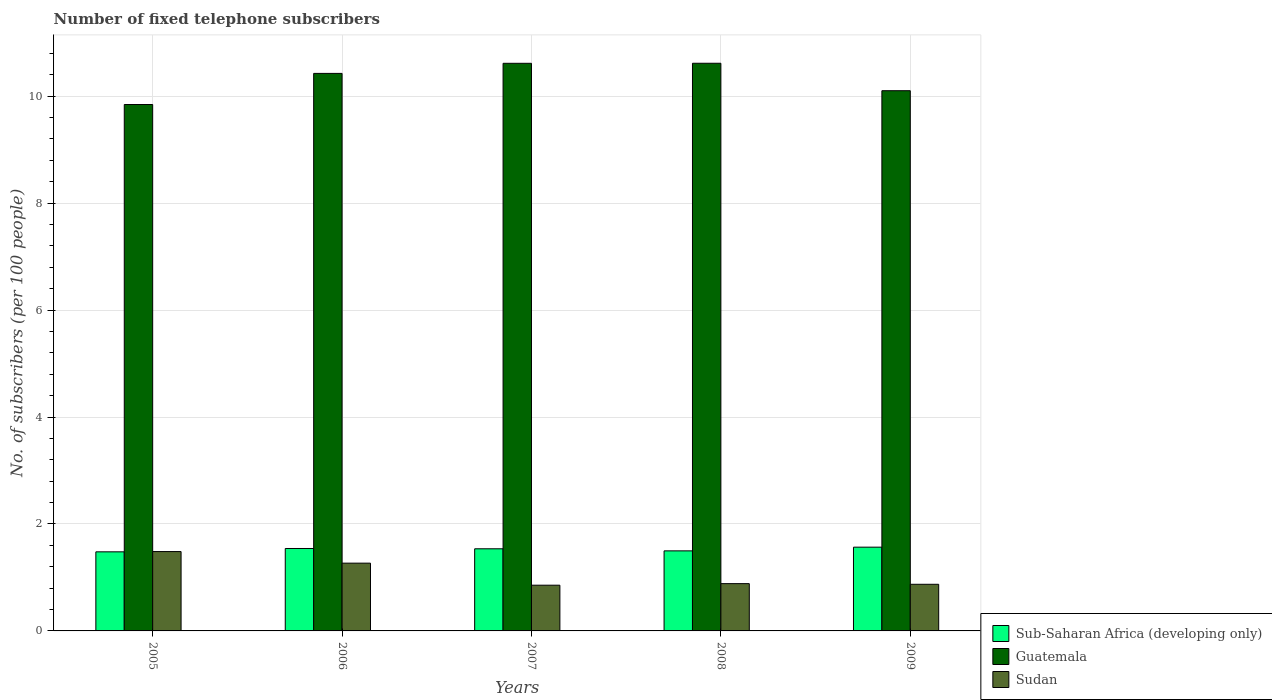How many different coloured bars are there?
Your answer should be very brief. 3. How many groups of bars are there?
Your answer should be compact. 5. Are the number of bars per tick equal to the number of legend labels?
Your response must be concise. Yes. How many bars are there on the 4th tick from the left?
Your answer should be compact. 3. What is the number of fixed telephone subscribers in Sub-Saharan Africa (developing only) in 2007?
Provide a short and direct response. 1.54. Across all years, what is the maximum number of fixed telephone subscribers in Sub-Saharan Africa (developing only)?
Your answer should be very brief. 1.57. Across all years, what is the minimum number of fixed telephone subscribers in Sub-Saharan Africa (developing only)?
Your answer should be compact. 1.48. In which year was the number of fixed telephone subscribers in Sudan maximum?
Provide a short and direct response. 2005. What is the total number of fixed telephone subscribers in Guatemala in the graph?
Provide a short and direct response. 51.6. What is the difference between the number of fixed telephone subscribers in Guatemala in 2007 and that in 2008?
Offer a very short reply. -0. What is the difference between the number of fixed telephone subscribers in Sub-Saharan Africa (developing only) in 2008 and the number of fixed telephone subscribers in Sudan in 2006?
Your answer should be very brief. 0.23. What is the average number of fixed telephone subscribers in Guatemala per year?
Ensure brevity in your answer.  10.32. In the year 2009, what is the difference between the number of fixed telephone subscribers in Sudan and number of fixed telephone subscribers in Guatemala?
Give a very brief answer. -9.23. What is the ratio of the number of fixed telephone subscribers in Sub-Saharan Africa (developing only) in 2005 to that in 2007?
Offer a very short reply. 0.96. Is the number of fixed telephone subscribers in Sub-Saharan Africa (developing only) in 2008 less than that in 2009?
Keep it short and to the point. Yes. Is the difference between the number of fixed telephone subscribers in Sudan in 2005 and 2006 greater than the difference between the number of fixed telephone subscribers in Guatemala in 2005 and 2006?
Offer a very short reply. Yes. What is the difference between the highest and the second highest number of fixed telephone subscribers in Guatemala?
Offer a very short reply. 0. What is the difference between the highest and the lowest number of fixed telephone subscribers in Sudan?
Your answer should be very brief. 0.63. What does the 3rd bar from the left in 2007 represents?
Keep it short and to the point. Sudan. What does the 3rd bar from the right in 2008 represents?
Provide a succinct answer. Sub-Saharan Africa (developing only). Is it the case that in every year, the sum of the number of fixed telephone subscribers in Sudan and number of fixed telephone subscribers in Sub-Saharan Africa (developing only) is greater than the number of fixed telephone subscribers in Guatemala?
Offer a terse response. No. How many bars are there?
Keep it short and to the point. 15. Are all the bars in the graph horizontal?
Your answer should be compact. No. How many years are there in the graph?
Offer a very short reply. 5. What is the difference between two consecutive major ticks on the Y-axis?
Your answer should be very brief. 2. Are the values on the major ticks of Y-axis written in scientific E-notation?
Your answer should be very brief. No. Does the graph contain any zero values?
Give a very brief answer. No. How many legend labels are there?
Make the answer very short. 3. What is the title of the graph?
Keep it short and to the point. Number of fixed telephone subscribers. What is the label or title of the X-axis?
Keep it short and to the point. Years. What is the label or title of the Y-axis?
Give a very brief answer. No. of subscribers (per 100 people). What is the No. of subscribers (per 100 people) in Sub-Saharan Africa (developing only) in 2005?
Your response must be concise. 1.48. What is the No. of subscribers (per 100 people) in Guatemala in 2005?
Give a very brief answer. 9.84. What is the No. of subscribers (per 100 people) of Sudan in 2005?
Give a very brief answer. 1.48. What is the No. of subscribers (per 100 people) of Sub-Saharan Africa (developing only) in 2006?
Give a very brief answer. 1.54. What is the No. of subscribers (per 100 people) of Guatemala in 2006?
Your response must be concise. 10.43. What is the No. of subscribers (per 100 people) of Sudan in 2006?
Offer a very short reply. 1.27. What is the No. of subscribers (per 100 people) in Sub-Saharan Africa (developing only) in 2007?
Offer a terse response. 1.54. What is the No. of subscribers (per 100 people) of Guatemala in 2007?
Offer a very short reply. 10.61. What is the No. of subscribers (per 100 people) in Sudan in 2007?
Ensure brevity in your answer.  0.85. What is the No. of subscribers (per 100 people) in Sub-Saharan Africa (developing only) in 2008?
Your answer should be very brief. 1.5. What is the No. of subscribers (per 100 people) of Guatemala in 2008?
Give a very brief answer. 10.62. What is the No. of subscribers (per 100 people) in Sudan in 2008?
Offer a terse response. 0.88. What is the No. of subscribers (per 100 people) in Sub-Saharan Africa (developing only) in 2009?
Give a very brief answer. 1.57. What is the No. of subscribers (per 100 people) of Guatemala in 2009?
Provide a succinct answer. 10.1. What is the No. of subscribers (per 100 people) in Sudan in 2009?
Ensure brevity in your answer.  0.87. Across all years, what is the maximum No. of subscribers (per 100 people) of Sub-Saharan Africa (developing only)?
Give a very brief answer. 1.57. Across all years, what is the maximum No. of subscribers (per 100 people) of Guatemala?
Make the answer very short. 10.62. Across all years, what is the maximum No. of subscribers (per 100 people) in Sudan?
Your response must be concise. 1.48. Across all years, what is the minimum No. of subscribers (per 100 people) in Sub-Saharan Africa (developing only)?
Your answer should be very brief. 1.48. Across all years, what is the minimum No. of subscribers (per 100 people) in Guatemala?
Ensure brevity in your answer.  9.84. Across all years, what is the minimum No. of subscribers (per 100 people) of Sudan?
Give a very brief answer. 0.85. What is the total No. of subscribers (per 100 people) of Sub-Saharan Africa (developing only) in the graph?
Offer a terse response. 7.62. What is the total No. of subscribers (per 100 people) of Guatemala in the graph?
Your answer should be compact. 51.6. What is the total No. of subscribers (per 100 people) of Sudan in the graph?
Offer a very short reply. 5.36. What is the difference between the No. of subscribers (per 100 people) in Sub-Saharan Africa (developing only) in 2005 and that in 2006?
Your response must be concise. -0.06. What is the difference between the No. of subscribers (per 100 people) of Guatemala in 2005 and that in 2006?
Your answer should be compact. -0.58. What is the difference between the No. of subscribers (per 100 people) of Sudan in 2005 and that in 2006?
Provide a succinct answer. 0.22. What is the difference between the No. of subscribers (per 100 people) of Sub-Saharan Africa (developing only) in 2005 and that in 2007?
Offer a terse response. -0.06. What is the difference between the No. of subscribers (per 100 people) in Guatemala in 2005 and that in 2007?
Offer a very short reply. -0.77. What is the difference between the No. of subscribers (per 100 people) of Sudan in 2005 and that in 2007?
Make the answer very short. 0.63. What is the difference between the No. of subscribers (per 100 people) in Sub-Saharan Africa (developing only) in 2005 and that in 2008?
Give a very brief answer. -0.02. What is the difference between the No. of subscribers (per 100 people) of Guatemala in 2005 and that in 2008?
Provide a succinct answer. -0.77. What is the difference between the No. of subscribers (per 100 people) in Sudan in 2005 and that in 2008?
Offer a very short reply. 0.6. What is the difference between the No. of subscribers (per 100 people) in Sub-Saharan Africa (developing only) in 2005 and that in 2009?
Your response must be concise. -0.09. What is the difference between the No. of subscribers (per 100 people) of Guatemala in 2005 and that in 2009?
Your answer should be very brief. -0.26. What is the difference between the No. of subscribers (per 100 people) of Sudan in 2005 and that in 2009?
Ensure brevity in your answer.  0.61. What is the difference between the No. of subscribers (per 100 people) of Sub-Saharan Africa (developing only) in 2006 and that in 2007?
Make the answer very short. 0.01. What is the difference between the No. of subscribers (per 100 people) of Guatemala in 2006 and that in 2007?
Your answer should be compact. -0.19. What is the difference between the No. of subscribers (per 100 people) of Sudan in 2006 and that in 2007?
Give a very brief answer. 0.41. What is the difference between the No. of subscribers (per 100 people) of Sub-Saharan Africa (developing only) in 2006 and that in 2008?
Offer a very short reply. 0.04. What is the difference between the No. of subscribers (per 100 people) of Guatemala in 2006 and that in 2008?
Keep it short and to the point. -0.19. What is the difference between the No. of subscribers (per 100 people) of Sudan in 2006 and that in 2008?
Ensure brevity in your answer.  0.38. What is the difference between the No. of subscribers (per 100 people) in Sub-Saharan Africa (developing only) in 2006 and that in 2009?
Offer a very short reply. -0.02. What is the difference between the No. of subscribers (per 100 people) of Guatemala in 2006 and that in 2009?
Your answer should be very brief. 0.32. What is the difference between the No. of subscribers (per 100 people) in Sudan in 2006 and that in 2009?
Keep it short and to the point. 0.4. What is the difference between the No. of subscribers (per 100 people) in Sub-Saharan Africa (developing only) in 2007 and that in 2008?
Ensure brevity in your answer.  0.04. What is the difference between the No. of subscribers (per 100 people) of Guatemala in 2007 and that in 2008?
Offer a terse response. -0. What is the difference between the No. of subscribers (per 100 people) in Sudan in 2007 and that in 2008?
Make the answer very short. -0.03. What is the difference between the No. of subscribers (per 100 people) of Sub-Saharan Africa (developing only) in 2007 and that in 2009?
Your answer should be compact. -0.03. What is the difference between the No. of subscribers (per 100 people) in Guatemala in 2007 and that in 2009?
Your answer should be compact. 0.51. What is the difference between the No. of subscribers (per 100 people) in Sudan in 2007 and that in 2009?
Make the answer very short. -0.02. What is the difference between the No. of subscribers (per 100 people) of Sub-Saharan Africa (developing only) in 2008 and that in 2009?
Provide a short and direct response. -0.07. What is the difference between the No. of subscribers (per 100 people) of Guatemala in 2008 and that in 2009?
Make the answer very short. 0.51. What is the difference between the No. of subscribers (per 100 people) of Sudan in 2008 and that in 2009?
Make the answer very short. 0.01. What is the difference between the No. of subscribers (per 100 people) of Sub-Saharan Africa (developing only) in 2005 and the No. of subscribers (per 100 people) of Guatemala in 2006?
Give a very brief answer. -8.95. What is the difference between the No. of subscribers (per 100 people) in Sub-Saharan Africa (developing only) in 2005 and the No. of subscribers (per 100 people) in Sudan in 2006?
Offer a very short reply. 0.21. What is the difference between the No. of subscribers (per 100 people) in Guatemala in 2005 and the No. of subscribers (per 100 people) in Sudan in 2006?
Keep it short and to the point. 8.58. What is the difference between the No. of subscribers (per 100 people) of Sub-Saharan Africa (developing only) in 2005 and the No. of subscribers (per 100 people) of Guatemala in 2007?
Your response must be concise. -9.14. What is the difference between the No. of subscribers (per 100 people) of Sub-Saharan Africa (developing only) in 2005 and the No. of subscribers (per 100 people) of Sudan in 2007?
Make the answer very short. 0.62. What is the difference between the No. of subscribers (per 100 people) in Guatemala in 2005 and the No. of subscribers (per 100 people) in Sudan in 2007?
Provide a short and direct response. 8.99. What is the difference between the No. of subscribers (per 100 people) of Sub-Saharan Africa (developing only) in 2005 and the No. of subscribers (per 100 people) of Guatemala in 2008?
Give a very brief answer. -9.14. What is the difference between the No. of subscribers (per 100 people) in Sub-Saharan Africa (developing only) in 2005 and the No. of subscribers (per 100 people) in Sudan in 2008?
Your answer should be very brief. 0.59. What is the difference between the No. of subscribers (per 100 people) of Guatemala in 2005 and the No. of subscribers (per 100 people) of Sudan in 2008?
Ensure brevity in your answer.  8.96. What is the difference between the No. of subscribers (per 100 people) in Sub-Saharan Africa (developing only) in 2005 and the No. of subscribers (per 100 people) in Guatemala in 2009?
Ensure brevity in your answer.  -8.62. What is the difference between the No. of subscribers (per 100 people) in Sub-Saharan Africa (developing only) in 2005 and the No. of subscribers (per 100 people) in Sudan in 2009?
Provide a short and direct response. 0.61. What is the difference between the No. of subscribers (per 100 people) in Guatemala in 2005 and the No. of subscribers (per 100 people) in Sudan in 2009?
Ensure brevity in your answer.  8.97. What is the difference between the No. of subscribers (per 100 people) in Sub-Saharan Africa (developing only) in 2006 and the No. of subscribers (per 100 people) in Guatemala in 2007?
Provide a short and direct response. -9.07. What is the difference between the No. of subscribers (per 100 people) of Sub-Saharan Africa (developing only) in 2006 and the No. of subscribers (per 100 people) of Sudan in 2007?
Give a very brief answer. 0.69. What is the difference between the No. of subscribers (per 100 people) of Guatemala in 2006 and the No. of subscribers (per 100 people) of Sudan in 2007?
Provide a succinct answer. 9.57. What is the difference between the No. of subscribers (per 100 people) of Sub-Saharan Africa (developing only) in 2006 and the No. of subscribers (per 100 people) of Guatemala in 2008?
Keep it short and to the point. -9.07. What is the difference between the No. of subscribers (per 100 people) of Sub-Saharan Africa (developing only) in 2006 and the No. of subscribers (per 100 people) of Sudan in 2008?
Offer a very short reply. 0.66. What is the difference between the No. of subscribers (per 100 people) of Guatemala in 2006 and the No. of subscribers (per 100 people) of Sudan in 2008?
Keep it short and to the point. 9.54. What is the difference between the No. of subscribers (per 100 people) of Sub-Saharan Africa (developing only) in 2006 and the No. of subscribers (per 100 people) of Guatemala in 2009?
Make the answer very short. -8.56. What is the difference between the No. of subscribers (per 100 people) of Sub-Saharan Africa (developing only) in 2006 and the No. of subscribers (per 100 people) of Sudan in 2009?
Provide a short and direct response. 0.67. What is the difference between the No. of subscribers (per 100 people) in Guatemala in 2006 and the No. of subscribers (per 100 people) in Sudan in 2009?
Keep it short and to the point. 9.55. What is the difference between the No. of subscribers (per 100 people) in Sub-Saharan Africa (developing only) in 2007 and the No. of subscribers (per 100 people) in Guatemala in 2008?
Give a very brief answer. -9.08. What is the difference between the No. of subscribers (per 100 people) in Sub-Saharan Africa (developing only) in 2007 and the No. of subscribers (per 100 people) in Sudan in 2008?
Make the answer very short. 0.65. What is the difference between the No. of subscribers (per 100 people) of Guatemala in 2007 and the No. of subscribers (per 100 people) of Sudan in 2008?
Your answer should be very brief. 9.73. What is the difference between the No. of subscribers (per 100 people) in Sub-Saharan Africa (developing only) in 2007 and the No. of subscribers (per 100 people) in Guatemala in 2009?
Provide a short and direct response. -8.57. What is the difference between the No. of subscribers (per 100 people) in Sub-Saharan Africa (developing only) in 2007 and the No. of subscribers (per 100 people) in Sudan in 2009?
Your response must be concise. 0.66. What is the difference between the No. of subscribers (per 100 people) of Guatemala in 2007 and the No. of subscribers (per 100 people) of Sudan in 2009?
Provide a succinct answer. 9.74. What is the difference between the No. of subscribers (per 100 people) of Sub-Saharan Africa (developing only) in 2008 and the No. of subscribers (per 100 people) of Guatemala in 2009?
Your response must be concise. -8.61. What is the difference between the No. of subscribers (per 100 people) in Sub-Saharan Africa (developing only) in 2008 and the No. of subscribers (per 100 people) in Sudan in 2009?
Keep it short and to the point. 0.63. What is the difference between the No. of subscribers (per 100 people) of Guatemala in 2008 and the No. of subscribers (per 100 people) of Sudan in 2009?
Keep it short and to the point. 9.74. What is the average No. of subscribers (per 100 people) of Sub-Saharan Africa (developing only) per year?
Your answer should be very brief. 1.52. What is the average No. of subscribers (per 100 people) in Guatemala per year?
Offer a very short reply. 10.32. What is the average No. of subscribers (per 100 people) of Sudan per year?
Your response must be concise. 1.07. In the year 2005, what is the difference between the No. of subscribers (per 100 people) in Sub-Saharan Africa (developing only) and No. of subscribers (per 100 people) in Guatemala?
Provide a succinct answer. -8.37. In the year 2005, what is the difference between the No. of subscribers (per 100 people) in Sub-Saharan Africa (developing only) and No. of subscribers (per 100 people) in Sudan?
Your response must be concise. -0.01. In the year 2005, what is the difference between the No. of subscribers (per 100 people) of Guatemala and No. of subscribers (per 100 people) of Sudan?
Give a very brief answer. 8.36. In the year 2006, what is the difference between the No. of subscribers (per 100 people) in Sub-Saharan Africa (developing only) and No. of subscribers (per 100 people) in Guatemala?
Keep it short and to the point. -8.88. In the year 2006, what is the difference between the No. of subscribers (per 100 people) of Sub-Saharan Africa (developing only) and No. of subscribers (per 100 people) of Sudan?
Give a very brief answer. 0.27. In the year 2006, what is the difference between the No. of subscribers (per 100 people) in Guatemala and No. of subscribers (per 100 people) in Sudan?
Keep it short and to the point. 9.16. In the year 2007, what is the difference between the No. of subscribers (per 100 people) in Sub-Saharan Africa (developing only) and No. of subscribers (per 100 people) in Guatemala?
Provide a short and direct response. -9.08. In the year 2007, what is the difference between the No. of subscribers (per 100 people) of Sub-Saharan Africa (developing only) and No. of subscribers (per 100 people) of Sudan?
Offer a terse response. 0.68. In the year 2007, what is the difference between the No. of subscribers (per 100 people) in Guatemala and No. of subscribers (per 100 people) in Sudan?
Your answer should be very brief. 9.76. In the year 2008, what is the difference between the No. of subscribers (per 100 people) in Sub-Saharan Africa (developing only) and No. of subscribers (per 100 people) in Guatemala?
Your response must be concise. -9.12. In the year 2008, what is the difference between the No. of subscribers (per 100 people) of Sub-Saharan Africa (developing only) and No. of subscribers (per 100 people) of Sudan?
Your answer should be compact. 0.61. In the year 2008, what is the difference between the No. of subscribers (per 100 people) of Guatemala and No. of subscribers (per 100 people) of Sudan?
Offer a very short reply. 9.73. In the year 2009, what is the difference between the No. of subscribers (per 100 people) in Sub-Saharan Africa (developing only) and No. of subscribers (per 100 people) in Guatemala?
Your answer should be compact. -8.54. In the year 2009, what is the difference between the No. of subscribers (per 100 people) in Sub-Saharan Africa (developing only) and No. of subscribers (per 100 people) in Sudan?
Ensure brevity in your answer.  0.69. In the year 2009, what is the difference between the No. of subscribers (per 100 people) in Guatemala and No. of subscribers (per 100 people) in Sudan?
Give a very brief answer. 9.23. What is the ratio of the No. of subscribers (per 100 people) in Sub-Saharan Africa (developing only) in 2005 to that in 2006?
Your response must be concise. 0.96. What is the ratio of the No. of subscribers (per 100 people) of Guatemala in 2005 to that in 2006?
Your response must be concise. 0.94. What is the ratio of the No. of subscribers (per 100 people) in Sudan in 2005 to that in 2006?
Ensure brevity in your answer.  1.17. What is the ratio of the No. of subscribers (per 100 people) of Sub-Saharan Africa (developing only) in 2005 to that in 2007?
Ensure brevity in your answer.  0.96. What is the ratio of the No. of subscribers (per 100 people) in Guatemala in 2005 to that in 2007?
Keep it short and to the point. 0.93. What is the ratio of the No. of subscribers (per 100 people) in Sudan in 2005 to that in 2007?
Your answer should be compact. 1.74. What is the ratio of the No. of subscribers (per 100 people) of Guatemala in 2005 to that in 2008?
Give a very brief answer. 0.93. What is the ratio of the No. of subscribers (per 100 people) of Sudan in 2005 to that in 2008?
Ensure brevity in your answer.  1.68. What is the ratio of the No. of subscribers (per 100 people) of Sub-Saharan Africa (developing only) in 2005 to that in 2009?
Provide a succinct answer. 0.94. What is the ratio of the No. of subscribers (per 100 people) in Guatemala in 2005 to that in 2009?
Your response must be concise. 0.97. What is the ratio of the No. of subscribers (per 100 people) in Sudan in 2005 to that in 2009?
Provide a short and direct response. 1.7. What is the ratio of the No. of subscribers (per 100 people) of Sub-Saharan Africa (developing only) in 2006 to that in 2007?
Give a very brief answer. 1. What is the ratio of the No. of subscribers (per 100 people) of Guatemala in 2006 to that in 2007?
Keep it short and to the point. 0.98. What is the ratio of the No. of subscribers (per 100 people) of Sudan in 2006 to that in 2007?
Your answer should be very brief. 1.48. What is the ratio of the No. of subscribers (per 100 people) in Sub-Saharan Africa (developing only) in 2006 to that in 2008?
Offer a very short reply. 1.03. What is the ratio of the No. of subscribers (per 100 people) in Guatemala in 2006 to that in 2008?
Make the answer very short. 0.98. What is the ratio of the No. of subscribers (per 100 people) in Sudan in 2006 to that in 2008?
Keep it short and to the point. 1.43. What is the ratio of the No. of subscribers (per 100 people) of Sub-Saharan Africa (developing only) in 2006 to that in 2009?
Provide a short and direct response. 0.98. What is the ratio of the No. of subscribers (per 100 people) in Guatemala in 2006 to that in 2009?
Keep it short and to the point. 1.03. What is the ratio of the No. of subscribers (per 100 people) in Sudan in 2006 to that in 2009?
Your answer should be very brief. 1.45. What is the ratio of the No. of subscribers (per 100 people) in Sub-Saharan Africa (developing only) in 2007 to that in 2009?
Offer a very short reply. 0.98. What is the ratio of the No. of subscribers (per 100 people) of Guatemala in 2007 to that in 2009?
Provide a succinct answer. 1.05. What is the ratio of the No. of subscribers (per 100 people) of Sudan in 2007 to that in 2009?
Keep it short and to the point. 0.98. What is the ratio of the No. of subscribers (per 100 people) of Sub-Saharan Africa (developing only) in 2008 to that in 2009?
Your answer should be compact. 0.96. What is the ratio of the No. of subscribers (per 100 people) of Guatemala in 2008 to that in 2009?
Make the answer very short. 1.05. What is the difference between the highest and the second highest No. of subscribers (per 100 people) of Sub-Saharan Africa (developing only)?
Provide a succinct answer. 0.02. What is the difference between the highest and the second highest No. of subscribers (per 100 people) in Guatemala?
Make the answer very short. 0. What is the difference between the highest and the second highest No. of subscribers (per 100 people) of Sudan?
Make the answer very short. 0.22. What is the difference between the highest and the lowest No. of subscribers (per 100 people) of Sub-Saharan Africa (developing only)?
Make the answer very short. 0.09. What is the difference between the highest and the lowest No. of subscribers (per 100 people) in Guatemala?
Offer a terse response. 0.77. What is the difference between the highest and the lowest No. of subscribers (per 100 people) in Sudan?
Your answer should be very brief. 0.63. 